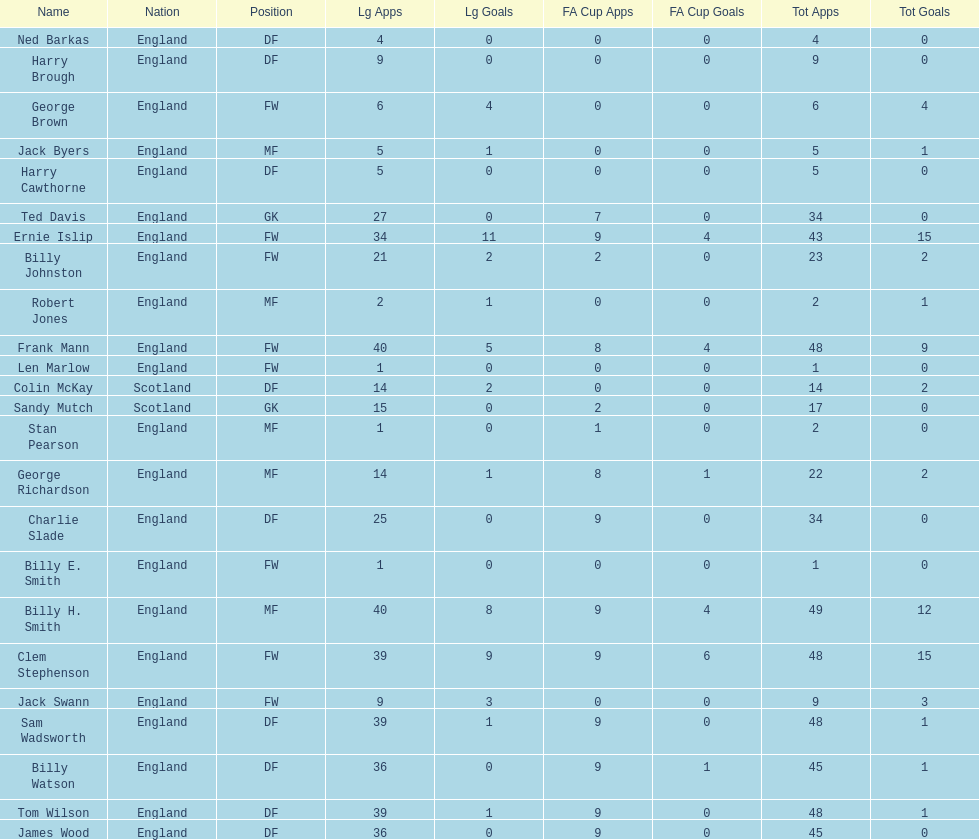Which position is listed the least amount of times on this chart? GK. 